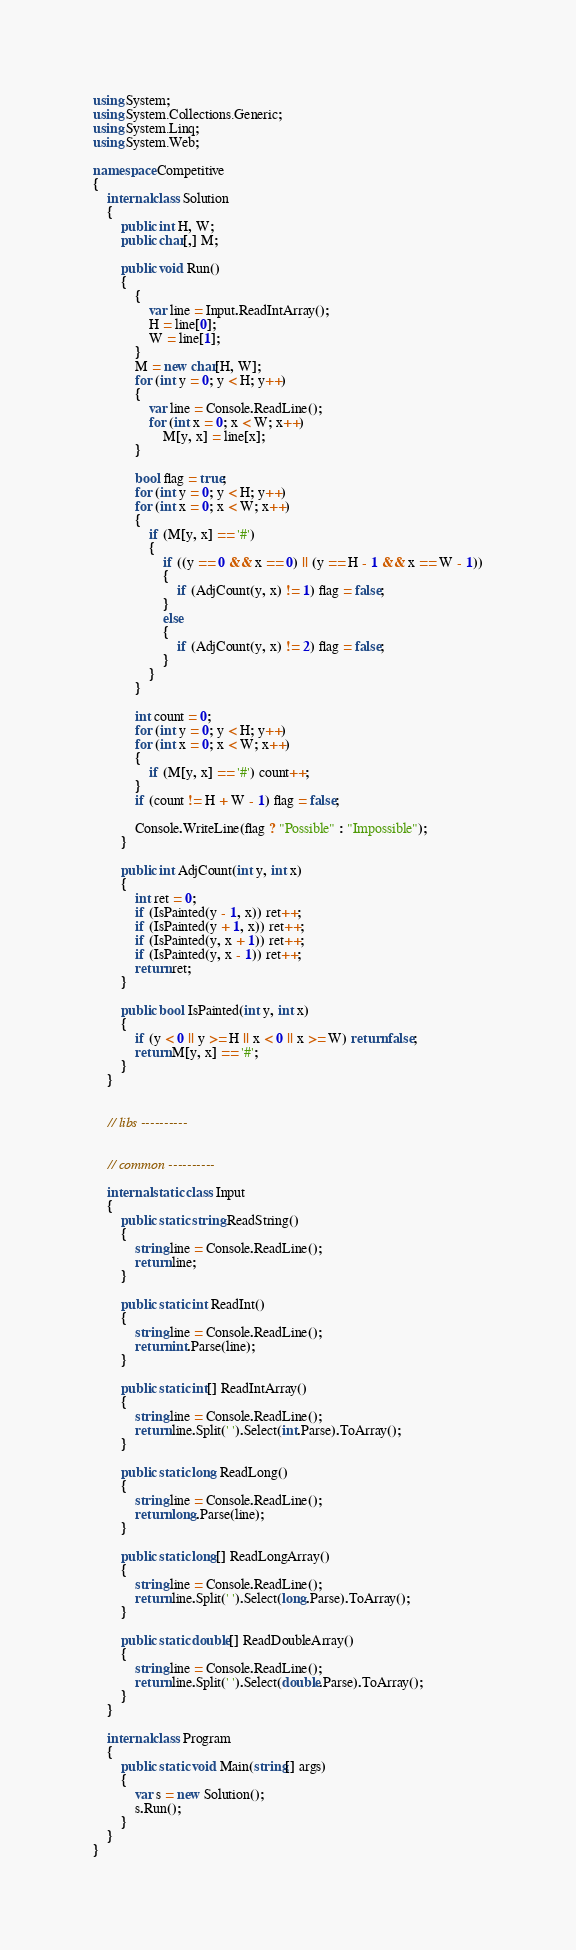<code> <loc_0><loc_0><loc_500><loc_500><_C#_>using System;
using System.Collections.Generic;
using System.Linq;
using System.Web;

namespace Competitive
{
    internal class Solution
    {
        public int H, W;
        public char[,] M;

        public void Run()
        {
            {
                var line = Input.ReadIntArray();
                H = line[0];
                W = line[1];
            }
            M = new char[H, W];
            for (int y = 0; y < H; y++)
            {
                var line = Console.ReadLine();
                for (int x = 0; x < W; x++)
                    M[y, x] = line[x];
            }

            bool flag = true;
            for (int y = 0; y < H; y++)
            for (int x = 0; x < W; x++)
            {
                if (M[y, x] == '#')
                {
                    if ((y == 0 && x == 0) || (y == H - 1 && x == W - 1))
                    {
                        if (AdjCount(y, x) != 1) flag = false;
                    }
                    else
                    {
                        if (AdjCount(y, x) != 2) flag = false;
                    }
                }
            }

            int count = 0;
            for (int y = 0; y < H; y++)
            for (int x = 0; x < W; x++)
            {
                if (M[y, x] == '#') count++;
            }
            if (count != H + W - 1) flag = false;

            Console.WriteLine(flag ? "Possible" : "Impossible");
        }

        public int AdjCount(int y, int x)
        {
            int ret = 0;
            if (IsPainted(y - 1, x)) ret++;
            if (IsPainted(y + 1, x)) ret++;
            if (IsPainted(y, x + 1)) ret++;
            if (IsPainted(y, x - 1)) ret++;
            return ret;
        }

        public bool IsPainted(int y, int x)
        {
            if (y < 0 || y >= H || x < 0 || x >= W) return false;
            return M[y, x] == '#';
        }
    }


    // libs ----------


    // common ----------

    internal static class Input
    {
        public static string ReadString()
        {
            string line = Console.ReadLine();
            return line;
        }

        public static int ReadInt()
        {
            string line = Console.ReadLine();
            return int.Parse(line);
        }

        public static int[] ReadIntArray()
        {
            string line = Console.ReadLine();
            return line.Split(' ').Select(int.Parse).ToArray();            
        }

        public static long ReadLong()
        {
            string line = Console.ReadLine();
            return long.Parse(line);
        }

        public static long[] ReadLongArray()
        {
            string line = Console.ReadLine();
            return line.Split(' ').Select(long.Parse).ToArray();
        }

        public static double[] ReadDoubleArray()
        {
            string line = Console.ReadLine();
            return line.Split(' ').Select(double.Parse).ToArray();
        }
    }
    
    internal class Program
    {
        public static void Main(string[] args)
        {
            var s = new Solution();
            s.Run();
        }
    }
}</code> 